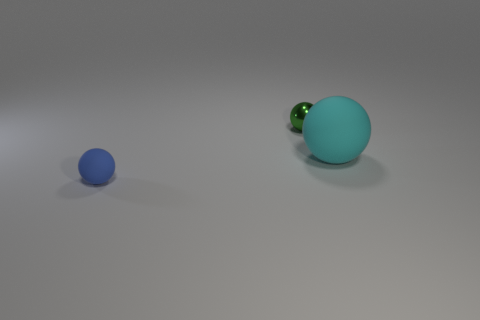
Are there any other things that are made of the same material as the green ball? It's not possible to determine the exact materials just from the image, but looking at the context, the blue ball appears to potentially be made of a similar material given its similar reflective quality and smooth texture. 